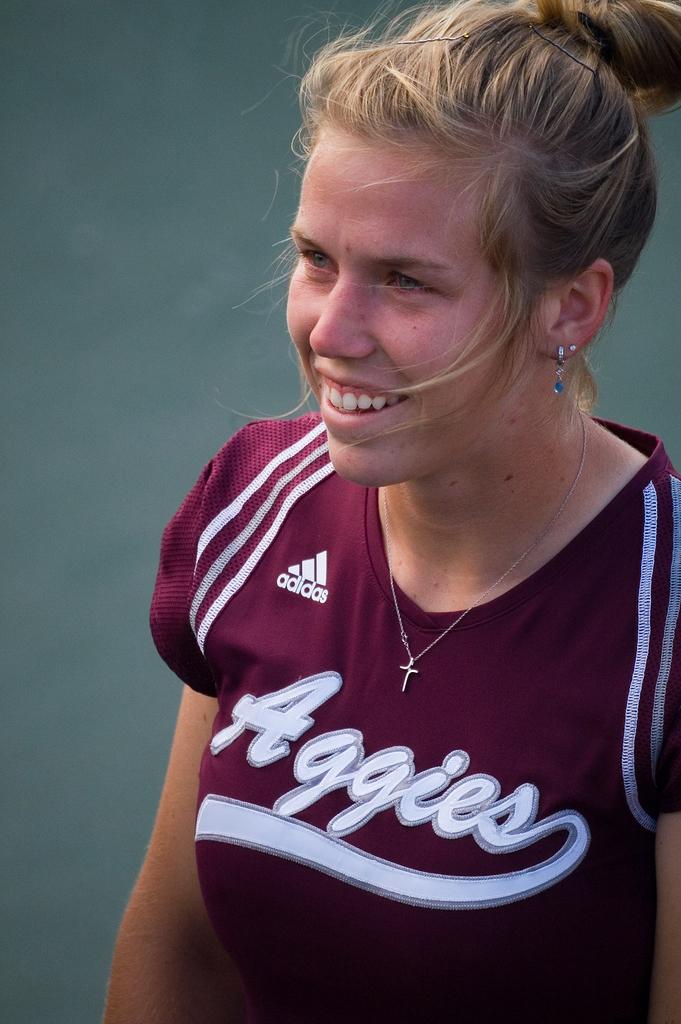What shoe brand is mentioned on the uniform?
Your response must be concise. Adidas. 